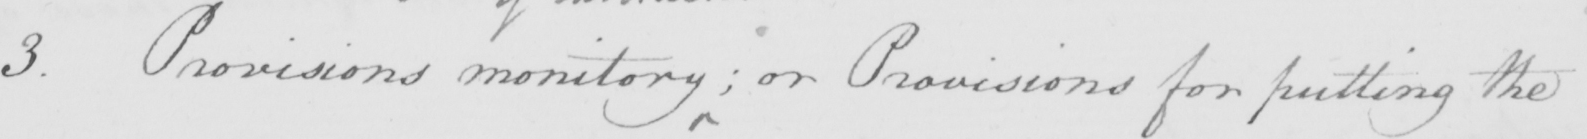Can you tell me what this handwritten text says? 3 . Provisions monitory  ; or Provisions for putting the 